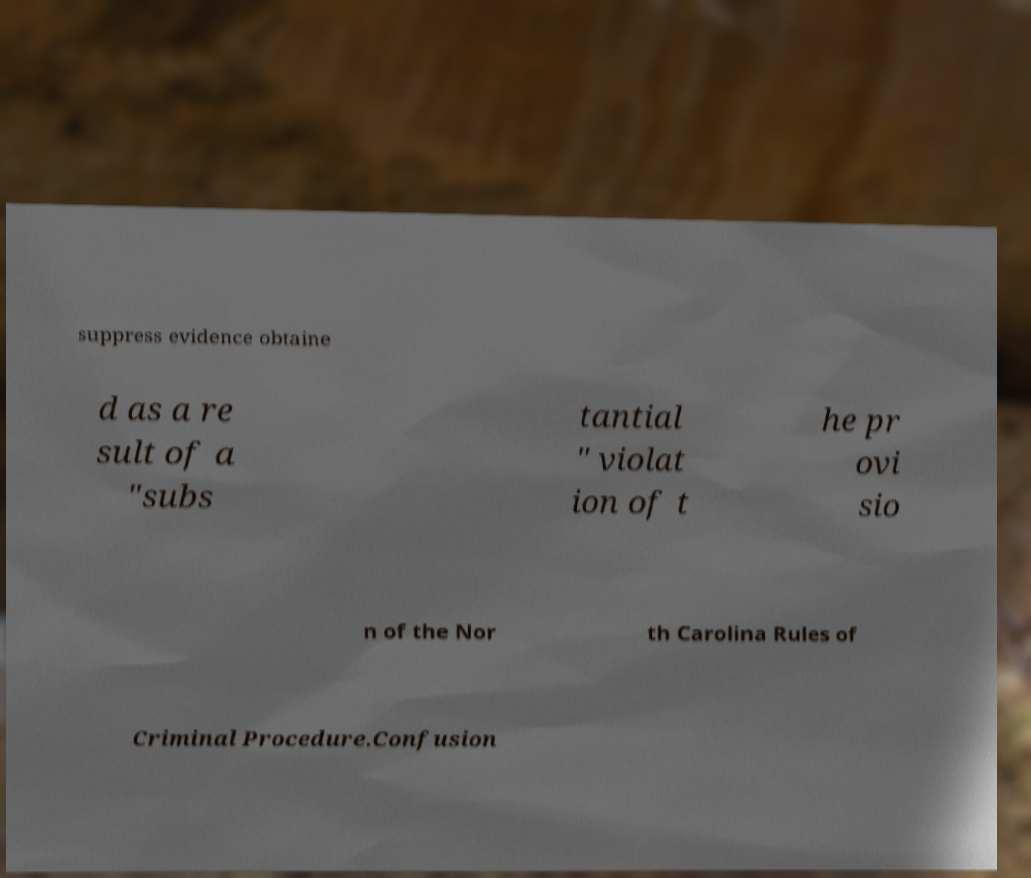For documentation purposes, I need the text within this image transcribed. Could you provide that? suppress evidence obtaine d as a re sult of a "subs tantial " violat ion of t he pr ovi sio n of the Nor th Carolina Rules of Criminal Procedure.Confusion 